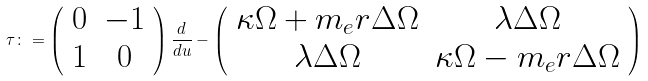<formula> <loc_0><loc_0><loc_500><loc_500>\tau \colon = \left ( \begin{array} { c c } 0 & - 1 \\ 1 & 0 \end{array} \right ) \frac { d } { d u } - \left ( \begin{array} { c c } \kappa \Omega + m _ { e } r \Delta \Omega & \lambda \Delta \Omega \\ \lambda \Delta \Omega & \kappa \Omega - m _ { e } r \Delta \Omega \end{array} \right )</formula> 